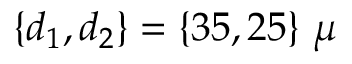Convert formula to latex. <formula><loc_0><loc_0><loc_500><loc_500>\{ d _ { 1 } , d _ { 2 } \} = \{ 3 5 , 2 5 \} \ \mu</formula> 